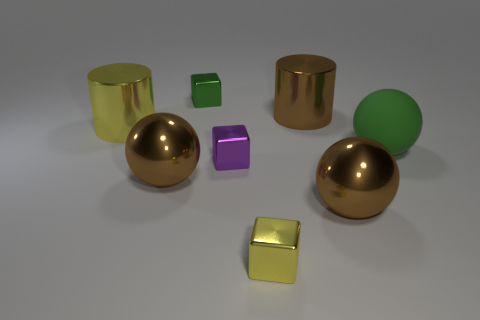Subtract all shiny balls. How many balls are left? 1 Subtract all red blocks. How many brown balls are left? 2 Add 1 big green rubber things. How many objects exist? 9 Subtract all cylinders. How many objects are left? 6 Subtract all yellow blocks. How many blocks are left? 2 Subtract 0 yellow spheres. How many objects are left? 8 Subtract all brown spheres. Subtract all gray cylinders. How many spheres are left? 1 Subtract all small purple objects. Subtract all large blue objects. How many objects are left? 7 Add 7 large rubber balls. How many large rubber balls are left? 8 Add 2 tiny green objects. How many tiny green objects exist? 3 